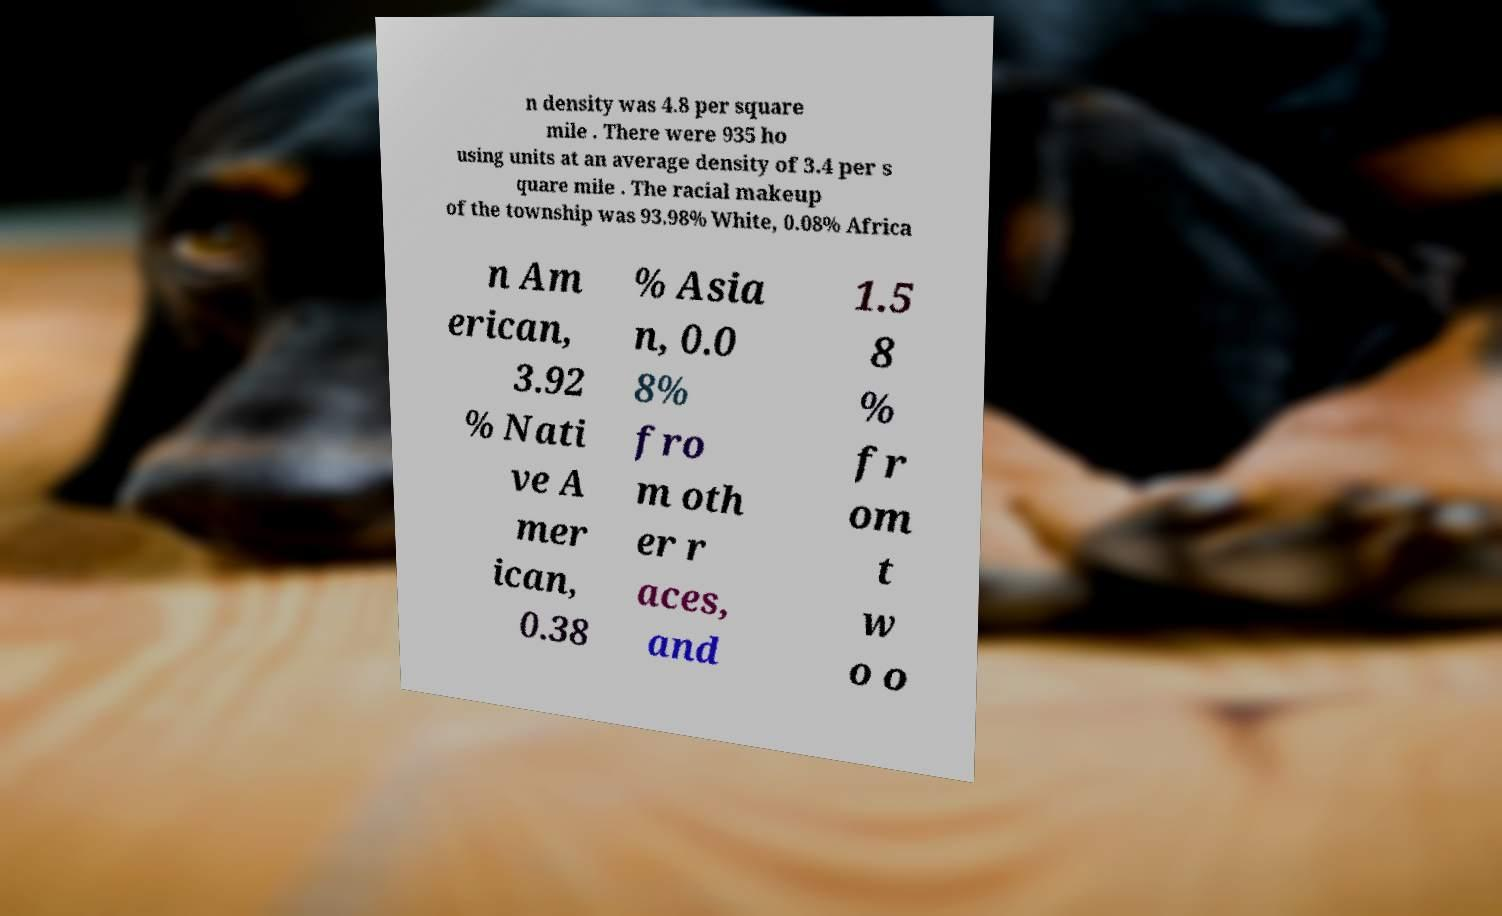Please read and relay the text visible in this image. What does it say? n density was 4.8 per square mile . There were 935 ho using units at an average density of 3.4 per s quare mile . The racial makeup of the township was 93.98% White, 0.08% Africa n Am erican, 3.92 % Nati ve A mer ican, 0.38 % Asia n, 0.0 8% fro m oth er r aces, and 1.5 8 % fr om t w o o 